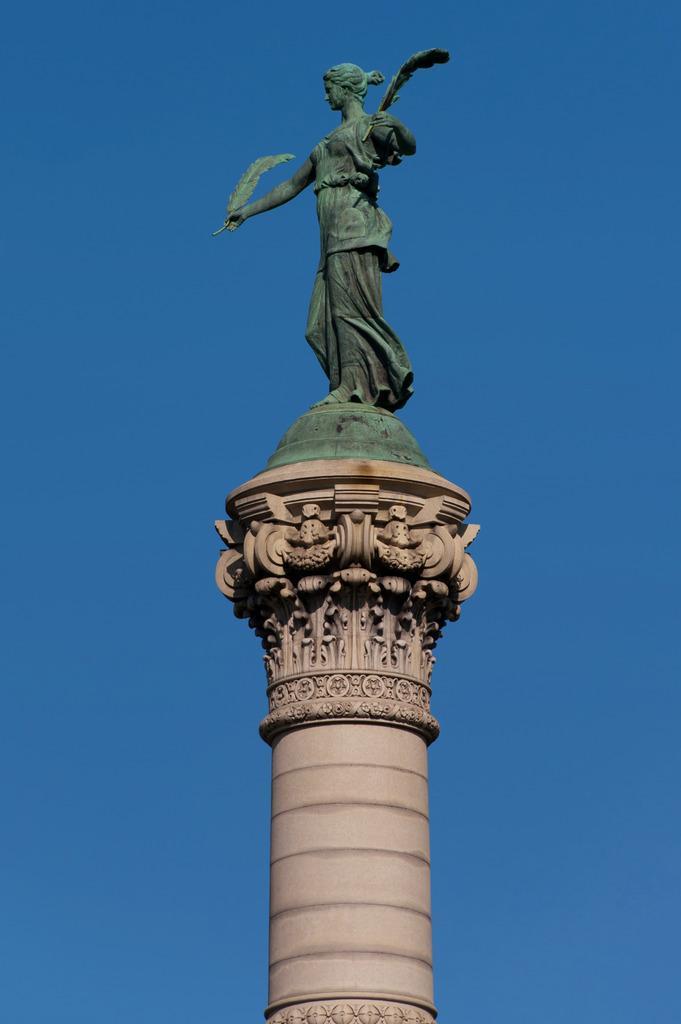In one or two sentences, can you explain what this image depicts? In the image there is a pillar with sculptures. On the top of the pillar there is a statue. And there is blue color background. 